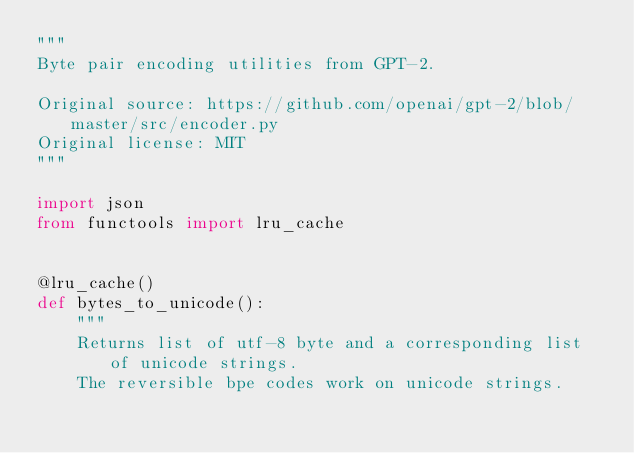Convert code to text. <code><loc_0><loc_0><loc_500><loc_500><_Python_>"""
Byte pair encoding utilities from GPT-2.

Original source: https://github.com/openai/gpt-2/blob/master/src/encoder.py
Original license: MIT
"""

import json
from functools import lru_cache


@lru_cache()
def bytes_to_unicode():
    """
    Returns list of utf-8 byte and a corresponding list of unicode strings.
    The reversible bpe codes work on unicode strings.</code> 